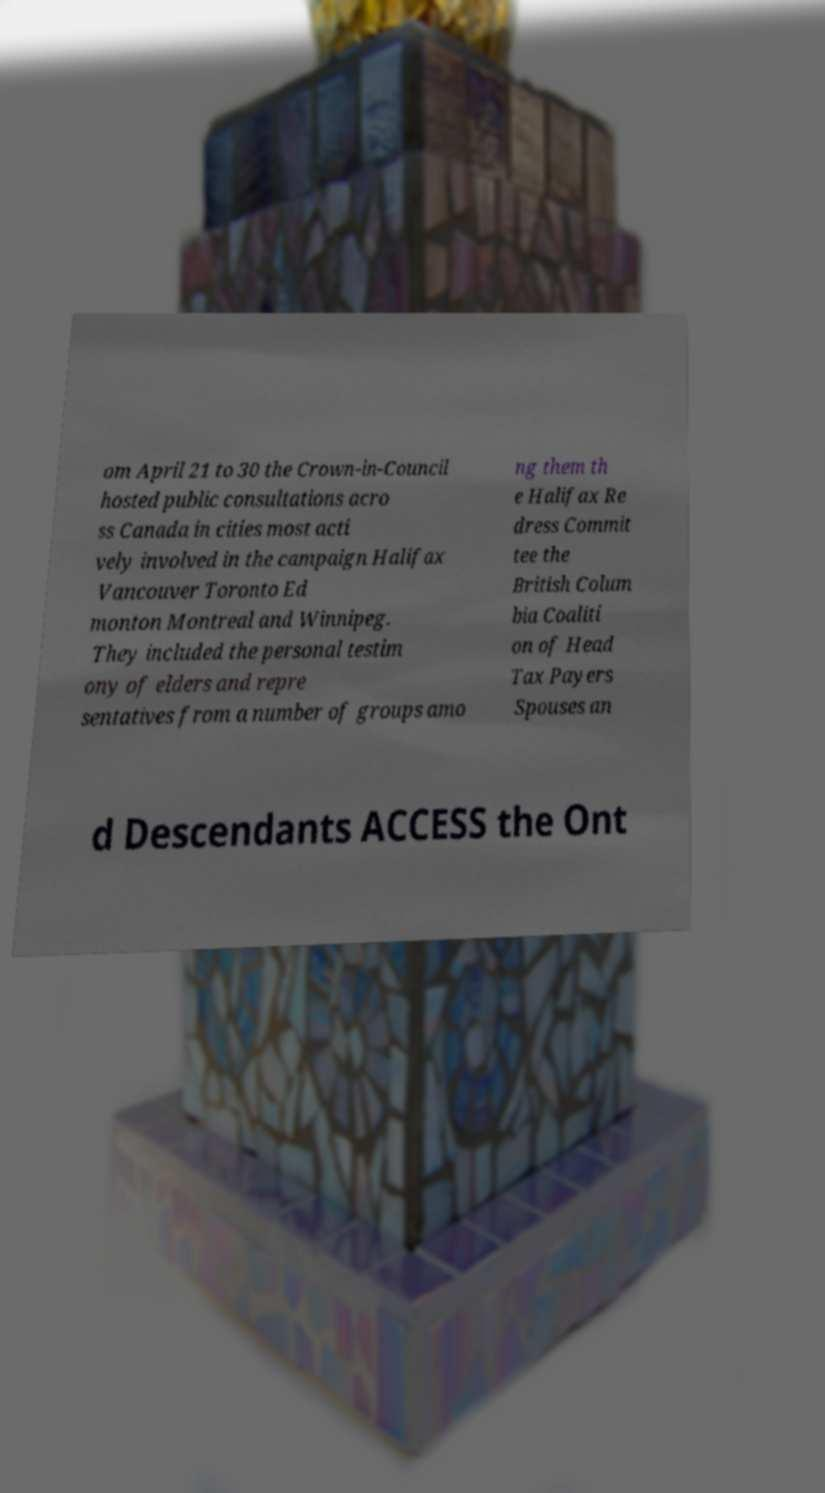I need the written content from this picture converted into text. Can you do that? om April 21 to 30 the Crown-in-Council hosted public consultations acro ss Canada in cities most acti vely involved in the campaign Halifax Vancouver Toronto Ed monton Montreal and Winnipeg. They included the personal testim ony of elders and repre sentatives from a number of groups amo ng them th e Halifax Re dress Commit tee the British Colum bia Coaliti on of Head Tax Payers Spouses an d Descendants ACCESS the Ont 